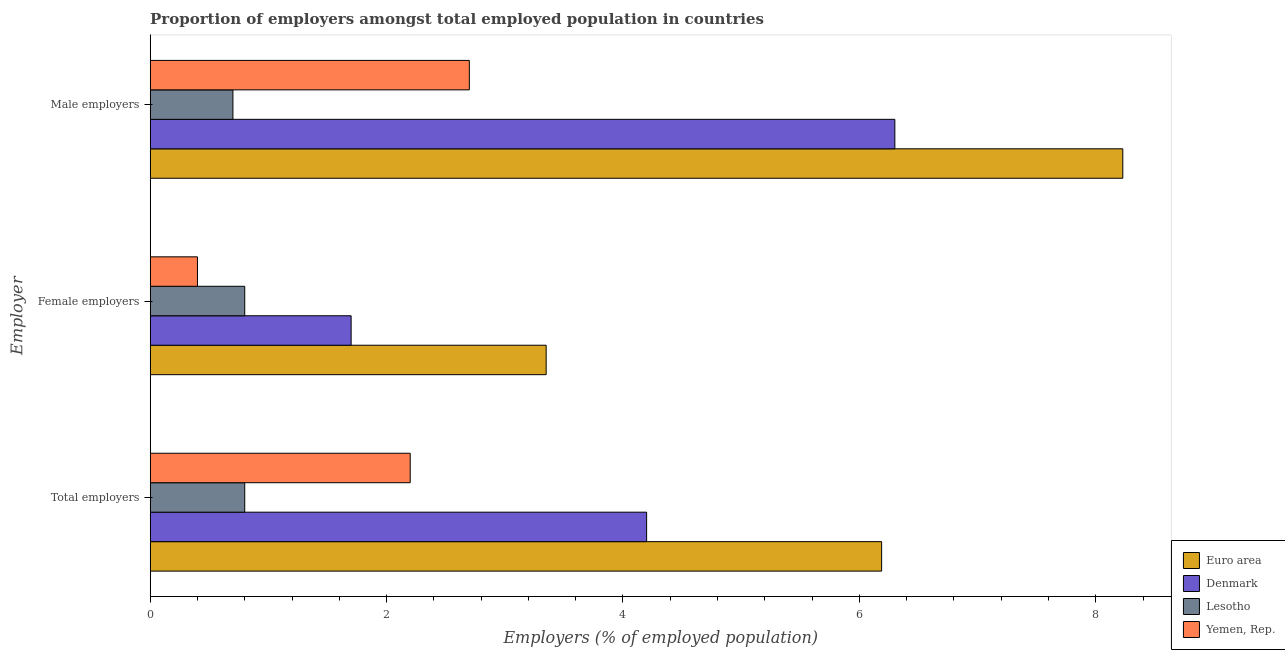How many different coloured bars are there?
Make the answer very short. 4. How many bars are there on the 1st tick from the top?
Your answer should be very brief. 4. How many bars are there on the 1st tick from the bottom?
Ensure brevity in your answer.  4. What is the label of the 2nd group of bars from the top?
Provide a succinct answer. Female employers. What is the percentage of total employers in Lesotho?
Give a very brief answer. 0.8. Across all countries, what is the maximum percentage of male employers?
Keep it short and to the point. 8.23. Across all countries, what is the minimum percentage of female employers?
Your response must be concise. 0.4. In which country was the percentage of total employers minimum?
Make the answer very short. Lesotho. What is the total percentage of total employers in the graph?
Your answer should be compact. 13.39. What is the difference between the percentage of male employers in Lesotho and that in Euro area?
Offer a terse response. -7.53. What is the difference between the percentage of total employers in Lesotho and the percentage of female employers in Denmark?
Offer a very short reply. -0.9. What is the average percentage of male employers per country?
Your answer should be compact. 4.48. What is the difference between the percentage of total employers and percentage of female employers in Euro area?
Your answer should be compact. 2.84. In how many countries, is the percentage of total employers greater than 5.6 %?
Give a very brief answer. 1. What is the ratio of the percentage of total employers in Denmark to that in Lesotho?
Your answer should be compact. 5.25. Is the percentage of total employers in Yemen, Rep. less than that in Denmark?
Provide a succinct answer. Yes. What is the difference between the highest and the second highest percentage of female employers?
Keep it short and to the point. 1.65. What is the difference between the highest and the lowest percentage of male employers?
Provide a short and direct response. 7.53. Is the sum of the percentage of male employers in Euro area and Denmark greater than the maximum percentage of total employers across all countries?
Your response must be concise. Yes. What does the 1st bar from the top in Female employers represents?
Give a very brief answer. Yemen, Rep. Are all the bars in the graph horizontal?
Offer a terse response. Yes. How many countries are there in the graph?
Make the answer very short. 4. What is the difference between two consecutive major ticks on the X-axis?
Make the answer very short. 2. Does the graph contain any zero values?
Make the answer very short. No. Does the graph contain grids?
Your answer should be very brief. No. Where does the legend appear in the graph?
Offer a terse response. Bottom right. How many legend labels are there?
Provide a succinct answer. 4. How are the legend labels stacked?
Provide a short and direct response. Vertical. What is the title of the graph?
Give a very brief answer. Proportion of employers amongst total employed population in countries. Does "Fiji" appear as one of the legend labels in the graph?
Keep it short and to the point. No. What is the label or title of the X-axis?
Offer a very short reply. Employers (% of employed population). What is the label or title of the Y-axis?
Offer a very short reply. Employer. What is the Employers (% of employed population) of Euro area in Total employers?
Give a very brief answer. 6.19. What is the Employers (% of employed population) in Denmark in Total employers?
Offer a terse response. 4.2. What is the Employers (% of employed population) in Lesotho in Total employers?
Offer a terse response. 0.8. What is the Employers (% of employed population) of Yemen, Rep. in Total employers?
Provide a short and direct response. 2.2. What is the Employers (% of employed population) of Euro area in Female employers?
Give a very brief answer. 3.35. What is the Employers (% of employed population) of Denmark in Female employers?
Your response must be concise. 1.7. What is the Employers (% of employed population) of Lesotho in Female employers?
Provide a succinct answer. 0.8. What is the Employers (% of employed population) in Yemen, Rep. in Female employers?
Offer a very short reply. 0.4. What is the Employers (% of employed population) of Euro area in Male employers?
Give a very brief answer. 8.23. What is the Employers (% of employed population) in Denmark in Male employers?
Your response must be concise. 6.3. What is the Employers (% of employed population) of Lesotho in Male employers?
Give a very brief answer. 0.7. What is the Employers (% of employed population) of Yemen, Rep. in Male employers?
Give a very brief answer. 2.7. Across all Employer, what is the maximum Employers (% of employed population) in Euro area?
Your answer should be compact. 8.23. Across all Employer, what is the maximum Employers (% of employed population) in Denmark?
Offer a very short reply. 6.3. Across all Employer, what is the maximum Employers (% of employed population) in Lesotho?
Offer a terse response. 0.8. Across all Employer, what is the maximum Employers (% of employed population) in Yemen, Rep.?
Your answer should be very brief. 2.7. Across all Employer, what is the minimum Employers (% of employed population) in Euro area?
Your answer should be compact. 3.35. Across all Employer, what is the minimum Employers (% of employed population) of Denmark?
Give a very brief answer. 1.7. Across all Employer, what is the minimum Employers (% of employed population) of Lesotho?
Your answer should be very brief. 0.7. Across all Employer, what is the minimum Employers (% of employed population) in Yemen, Rep.?
Ensure brevity in your answer.  0.4. What is the total Employers (% of employed population) of Euro area in the graph?
Make the answer very short. 17.77. What is the total Employers (% of employed population) in Denmark in the graph?
Provide a succinct answer. 12.2. What is the total Employers (% of employed population) of Yemen, Rep. in the graph?
Your answer should be very brief. 5.3. What is the difference between the Employers (% of employed population) in Euro area in Total employers and that in Female employers?
Offer a very short reply. 2.84. What is the difference between the Employers (% of employed population) in Lesotho in Total employers and that in Female employers?
Keep it short and to the point. 0. What is the difference between the Employers (% of employed population) in Yemen, Rep. in Total employers and that in Female employers?
Your answer should be compact. 1.8. What is the difference between the Employers (% of employed population) in Euro area in Total employers and that in Male employers?
Your answer should be compact. -2.04. What is the difference between the Employers (% of employed population) of Lesotho in Total employers and that in Male employers?
Make the answer very short. 0.1. What is the difference between the Employers (% of employed population) of Yemen, Rep. in Total employers and that in Male employers?
Offer a very short reply. -0.5. What is the difference between the Employers (% of employed population) of Euro area in Female employers and that in Male employers?
Offer a terse response. -4.88. What is the difference between the Employers (% of employed population) of Denmark in Female employers and that in Male employers?
Make the answer very short. -4.6. What is the difference between the Employers (% of employed population) of Lesotho in Female employers and that in Male employers?
Make the answer very short. 0.1. What is the difference between the Employers (% of employed population) of Euro area in Total employers and the Employers (% of employed population) of Denmark in Female employers?
Make the answer very short. 4.49. What is the difference between the Employers (% of employed population) of Euro area in Total employers and the Employers (% of employed population) of Lesotho in Female employers?
Provide a short and direct response. 5.39. What is the difference between the Employers (% of employed population) in Euro area in Total employers and the Employers (% of employed population) in Yemen, Rep. in Female employers?
Provide a short and direct response. 5.79. What is the difference between the Employers (% of employed population) of Lesotho in Total employers and the Employers (% of employed population) of Yemen, Rep. in Female employers?
Your response must be concise. 0.4. What is the difference between the Employers (% of employed population) in Euro area in Total employers and the Employers (% of employed population) in Denmark in Male employers?
Ensure brevity in your answer.  -0.11. What is the difference between the Employers (% of employed population) of Euro area in Total employers and the Employers (% of employed population) of Lesotho in Male employers?
Offer a very short reply. 5.49. What is the difference between the Employers (% of employed population) in Euro area in Total employers and the Employers (% of employed population) in Yemen, Rep. in Male employers?
Offer a very short reply. 3.49. What is the difference between the Employers (% of employed population) of Denmark in Total employers and the Employers (% of employed population) of Yemen, Rep. in Male employers?
Provide a short and direct response. 1.5. What is the difference between the Employers (% of employed population) of Euro area in Female employers and the Employers (% of employed population) of Denmark in Male employers?
Keep it short and to the point. -2.95. What is the difference between the Employers (% of employed population) of Euro area in Female employers and the Employers (% of employed population) of Lesotho in Male employers?
Offer a terse response. 2.65. What is the difference between the Employers (% of employed population) in Euro area in Female employers and the Employers (% of employed population) in Yemen, Rep. in Male employers?
Your answer should be compact. 0.65. What is the average Employers (% of employed population) in Euro area per Employer?
Make the answer very short. 5.92. What is the average Employers (% of employed population) in Denmark per Employer?
Ensure brevity in your answer.  4.07. What is the average Employers (% of employed population) in Lesotho per Employer?
Your answer should be very brief. 0.77. What is the average Employers (% of employed population) in Yemen, Rep. per Employer?
Give a very brief answer. 1.77. What is the difference between the Employers (% of employed population) of Euro area and Employers (% of employed population) of Denmark in Total employers?
Provide a short and direct response. 1.99. What is the difference between the Employers (% of employed population) of Euro area and Employers (% of employed population) of Lesotho in Total employers?
Your response must be concise. 5.39. What is the difference between the Employers (% of employed population) in Euro area and Employers (% of employed population) in Yemen, Rep. in Total employers?
Offer a terse response. 3.99. What is the difference between the Employers (% of employed population) of Denmark and Employers (% of employed population) of Lesotho in Total employers?
Make the answer very short. 3.4. What is the difference between the Employers (% of employed population) in Euro area and Employers (% of employed population) in Denmark in Female employers?
Provide a short and direct response. 1.65. What is the difference between the Employers (% of employed population) in Euro area and Employers (% of employed population) in Lesotho in Female employers?
Your response must be concise. 2.55. What is the difference between the Employers (% of employed population) in Euro area and Employers (% of employed population) in Yemen, Rep. in Female employers?
Offer a very short reply. 2.95. What is the difference between the Employers (% of employed population) in Denmark and Employers (% of employed population) in Yemen, Rep. in Female employers?
Ensure brevity in your answer.  1.3. What is the difference between the Employers (% of employed population) in Lesotho and Employers (% of employed population) in Yemen, Rep. in Female employers?
Provide a succinct answer. 0.4. What is the difference between the Employers (% of employed population) in Euro area and Employers (% of employed population) in Denmark in Male employers?
Give a very brief answer. 1.93. What is the difference between the Employers (% of employed population) in Euro area and Employers (% of employed population) in Lesotho in Male employers?
Ensure brevity in your answer.  7.53. What is the difference between the Employers (% of employed population) of Euro area and Employers (% of employed population) of Yemen, Rep. in Male employers?
Ensure brevity in your answer.  5.53. What is the difference between the Employers (% of employed population) in Denmark and Employers (% of employed population) in Lesotho in Male employers?
Provide a succinct answer. 5.6. What is the ratio of the Employers (% of employed population) in Euro area in Total employers to that in Female employers?
Offer a very short reply. 1.85. What is the ratio of the Employers (% of employed population) of Denmark in Total employers to that in Female employers?
Offer a terse response. 2.47. What is the ratio of the Employers (% of employed population) in Euro area in Total employers to that in Male employers?
Make the answer very short. 0.75. What is the ratio of the Employers (% of employed population) in Denmark in Total employers to that in Male employers?
Offer a very short reply. 0.67. What is the ratio of the Employers (% of employed population) in Lesotho in Total employers to that in Male employers?
Your response must be concise. 1.14. What is the ratio of the Employers (% of employed population) of Yemen, Rep. in Total employers to that in Male employers?
Offer a very short reply. 0.81. What is the ratio of the Employers (% of employed population) of Euro area in Female employers to that in Male employers?
Offer a terse response. 0.41. What is the ratio of the Employers (% of employed population) of Denmark in Female employers to that in Male employers?
Offer a terse response. 0.27. What is the ratio of the Employers (% of employed population) of Lesotho in Female employers to that in Male employers?
Ensure brevity in your answer.  1.14. What is the ratio of the Employers (% of employed population) in Yemen, Rep. in Female employers to that in Male employers?
Keep it short and to the point. 0.15. What is the difference between the highest and the second highest Employers (% of employed population) of Euro area?
Give a very brief answer. 2.04. What is the difference between the highest and the lowest Employers (% of employed population) in Euro area?
Offer a very short reply. 4.88. What is the difference between the highest and the lowest Employers (% of employed population) in Denmark?
Your answer should be very brief. 4.6. 